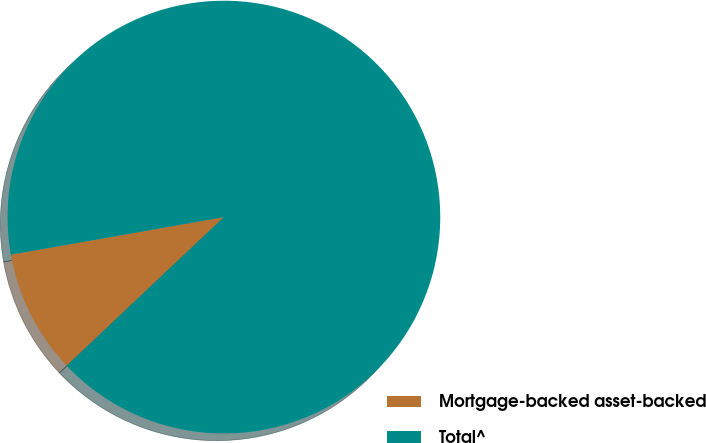Convert chart to OTSL. <chart><loc_0><loc_0><loc_500><loc_500><pie_chart><fcel>Mortgage-backed asset-backed<fcel>Total^<nl><fcel>9.27%<fcel>90.73%<nl></chart> 